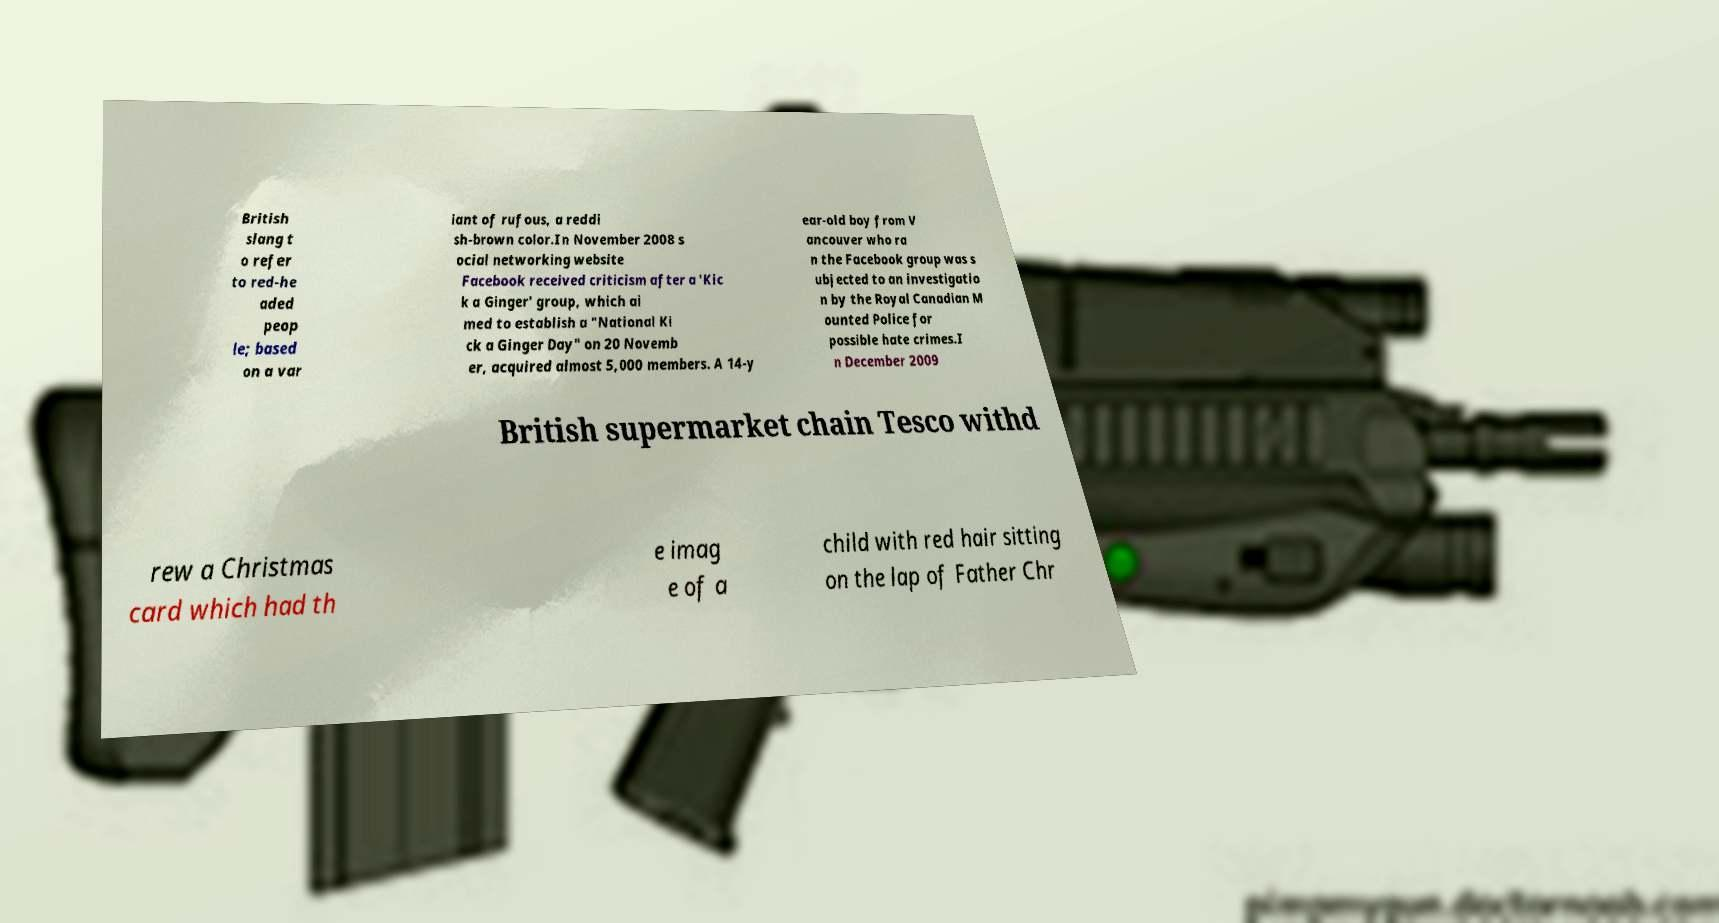What messages or text are displayed in this image? I need them in a readable, typed format. British slang t o refer to red-he aded peop le; based on a var iant of rufous, a reddi sh-brown color.In November 2008 s ocial networking website Facebook received criticism after a 'Kic k a Ginger' group, which ai med to establish a "National Ki ck a Ginger Day" on 20 Novemb er, acquired almost 5,000 members. A 14-y ear-old boy from V ancouver who ra n the Facebook group was s ubjected to an investigatio n by the Royal Canadian M ounted Police for possible hate crimes.I n December 2009 British supermarket chain Tesco withd rew a Christmas card which had th e imag e of a child with red hair sitting on the lap of Father Chr 